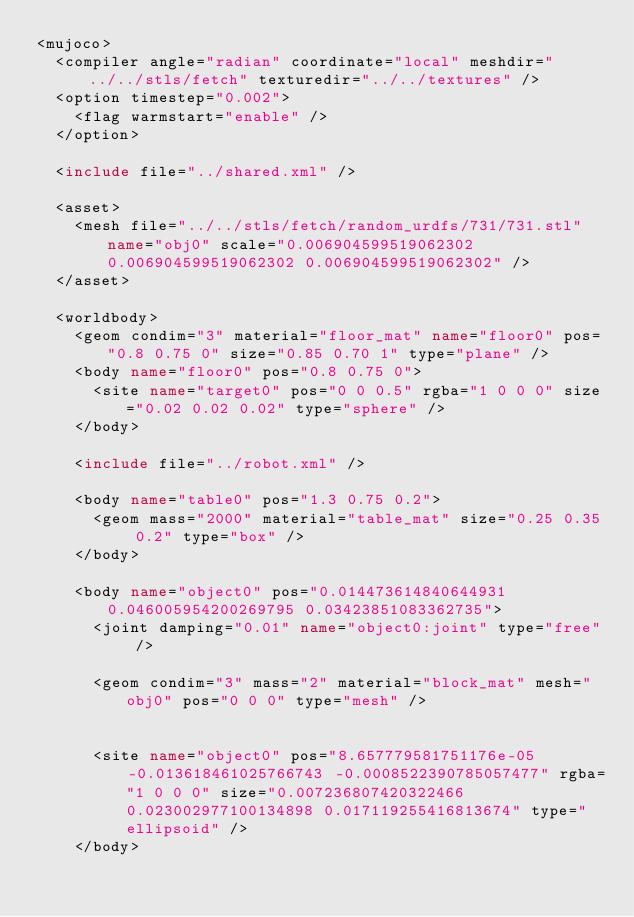Convert code to text. <code><loc_0><loc_0><loc_500><loc_500><_XML_><mujoco>
	<compiler angle="radian" coordinate="local" meshdir="../../stls/fetch" texturedir="../../textures" />
	<option timestep="0.002">
		<flag warmstart="enable" />
	</option>

	<include file="../shared.xml" />

	<asset>
		<mesh file="../../stls/fetch/random_urdfs/731/731.stl" name="obj0" scale="0.006904599519062302 0.006904599519062302 0.006904599519062302" />
	</asset>

	<worldbody>
		<geom condim="3" material="floor_mat" name="floor0" pos="0.8 0.75 0" size="0.85 0.70 1" type="plane" />
		<body name="floor0" pos="0.8 0.75 0">
			<site name="target0" pos="0 0 0.5" rgba="1 0 0 0" size="0.02 0.02 0.02" type="sphere" />
		</body>

		<include file="../robot.xml" />

		<body name="table0" pos="1.3 0.75 0.2">
			<geom mass="2000" material="table_mat" size="0.25 0.35 0.2" type="box" />
		</body>

		<body name="object0" pos="0.014473614840644931 0.046005954200269795 0.03423851083362735">
			<joint damping="0.01" name="object0:joint" type="free" />
			
			<geom condim="3" mass="2" material="block_mat" mesh="obj0" pos="0 0 0" type="mesh" />
			
			
			<site name="object0" pos="8.657779581751176e-05 -0.013618461025766743 -0.0008522390785057477" rgba="1 0 0 0" size="0.007236807420322466 0.023002977100134898 0.017119255416813674" type="ellipsoid" />
		</body>
</code> 